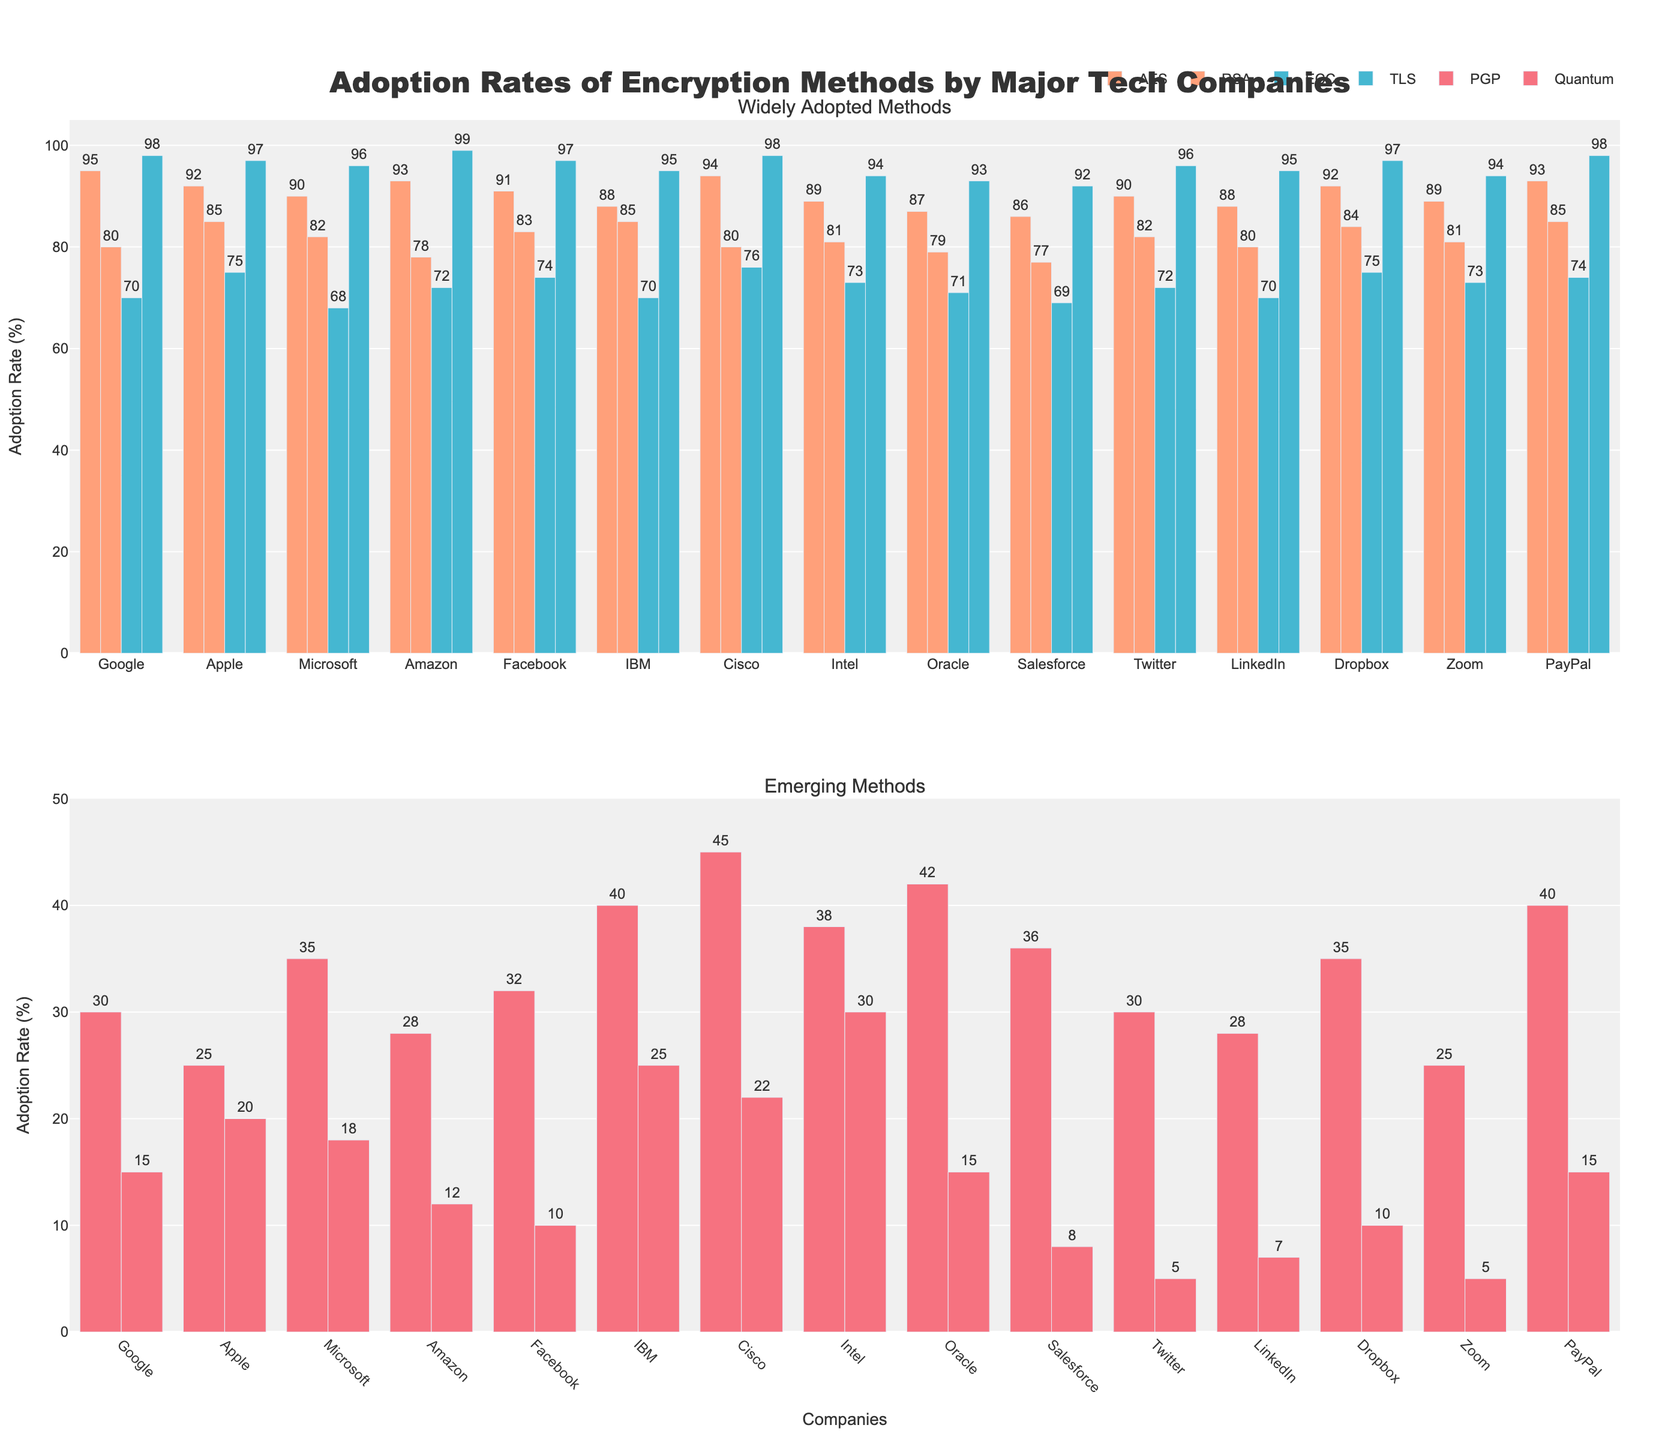What are the two encryption methods with the highest adoption rates among all companies? From the figure, the highest adoption rates can be identified by looking at the heights of the bars. AES and TLS are consistently high across all companies.
Answer: AES, TLS Which company has the highest adoption rate for Quantum encryption? The adoption rates for Quantum encryption are represented by bars in the second subplot (Emerging Methods). By comparing these bars, IBM has the highest rate.
Answer: IBM What is the average adoption rate of RSA encryption for Apple and Microsoft? To find the average, sum the RSA adoption rates for Apple and Microsoft (85 + 82) and divide by 2. 85 + 82 = 167, then 167 / 2 = 83.5.
Answer: 83.5 Compare the adoption rates of PGP encryption for Cisco and Intel. Which company has a higher rate? By looking at the PGP bars for Cisco and Intel in the second subplot, Cisco has a rate of 45 while Intel has a rate of 38. Hence, Cisco has the higher rate.
Answer: Cisco What is the total adoption rate of AES encryption across the first three companies listed (Google, Apple, Microsoft)? Sum the AES adoption rates for Google, Apple, and Microsoft (95 + 92 + 90). 95 + 92 = 187, then 187 + 90 = 277.
Answer: 277 Which encryption method shows a consistently high adoption rate but does not generally exceed 100% across all companies? Upon reviewing the first subplot (Widely Adopted Methods), it can be observed that ECC shows consistently high adoption rates but values are all below 100%.
Answer: ECC For Amazon, what is the difference in adoption rates between TLS and PGP encryption? The adoption rate for Amazon's TLS is 99, and for PGP it is 28. The difference is 99 - 28 = 71.
Answer: 71 What is the percentage difference in adoption rates of Quantum encryption between PayPal and Facebook? PayPal has an adoption rate of 15, and Facebook 10. The percentage difference is calculated by ((15 - 10) / 10) * 100 = 50%.
Answer: 50% How many companies have an adoption rate of 80% or more for RSA encryption? By examining the RSA bars across all companies in the first subplot, there are 11 companies (Google, Apple, Microsoft, Facebook, IBM, Cisco, Intel, Twitter, Dropbox, PayPal) with 80% or more.
Answer: 11 